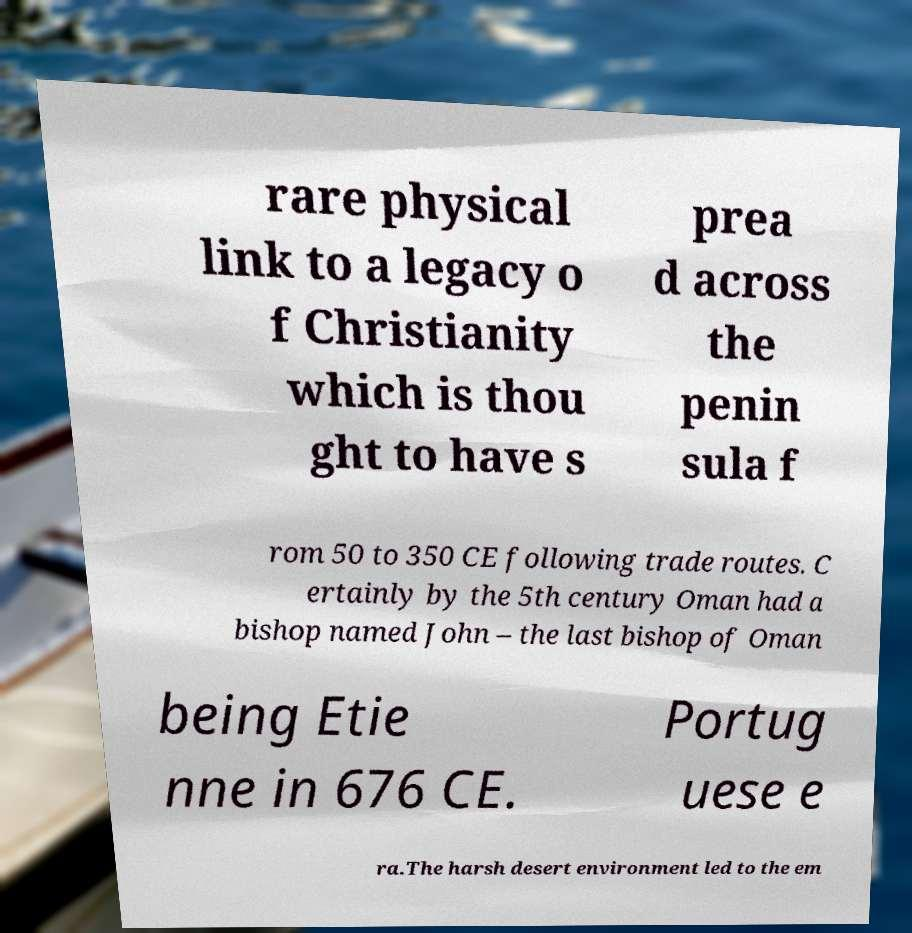Please read and relay the text visible in this image. What does it say? rare physical link to a legacy o f Christianity which is thou ght to have s prea d across the penin sula f rom 50 to 350 CE following trade routes. C ertainly by the 5th century Oman had a bishop named John – the last bishop of Oman being Etie nne in 676 CE. Portug uese e ra.The harsh desert environment led to the em 